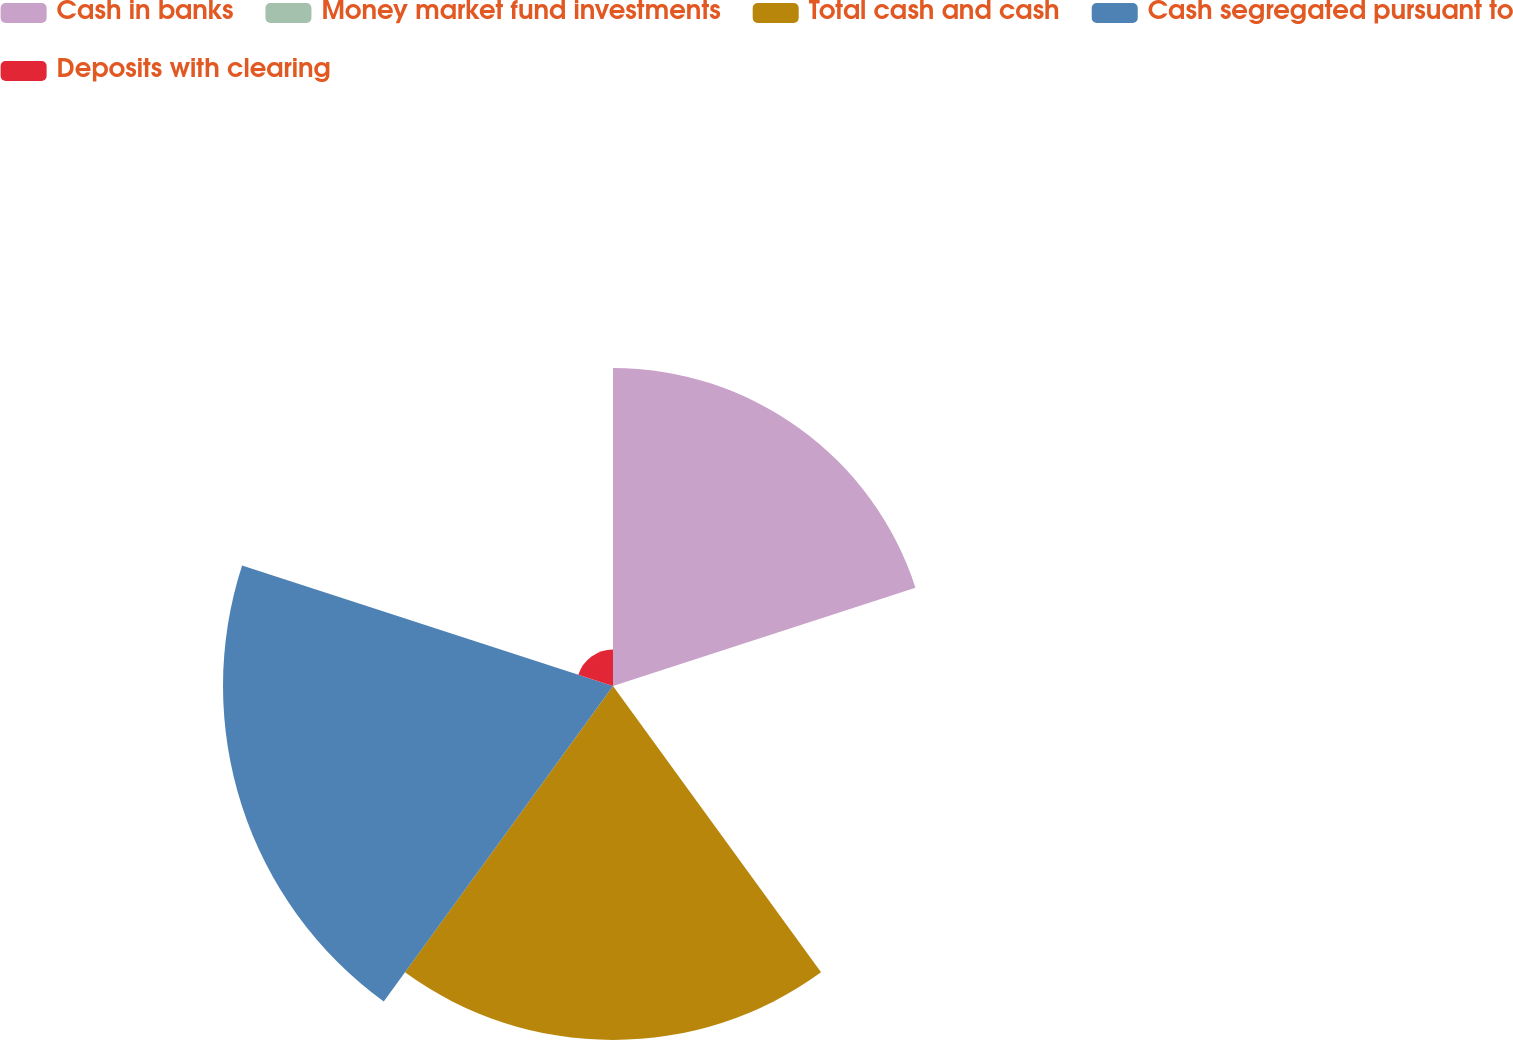<chart> <loc_0><loc_0><loc_500><loc_500><pie_chart><fcel>Cash in banks<fcel>Money market fund investments<fcel>Total cash and cash<fcel>Cash segregated pursuant to<fcel>Deposits with clearing<nl><fcel>28.94%<fcel>0.04%<fcel>32.21%<fcel>35.49%<fcel>3.32%<nl></chart> 